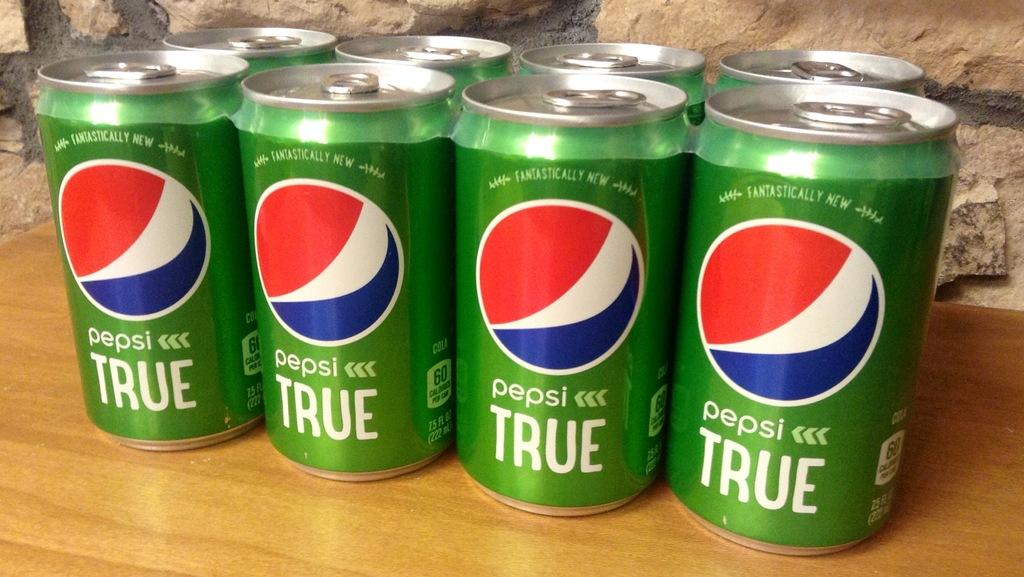<image>
Provide a brief description of the given image. An eight pack of green Pepsi true in cans. 